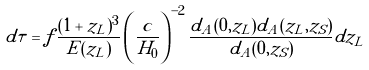<formula> <loc_0><loc_0><loc_500><loc_500>d \tau = f \frac { ( 1 + z _ { L } ) ^ { 3 } } { E ( z _ { L } ) } \left ( \frac { c } { H _ { 0 } } \right ) ^ { - 2 } \frac { d _ { A } ( 0 , z _ { L } ) d _ { A } ( z _ { L } , z _ { S } ) } { d _ { A } ( 0 , z _ { S } ) } d z _ { L }</formula> 